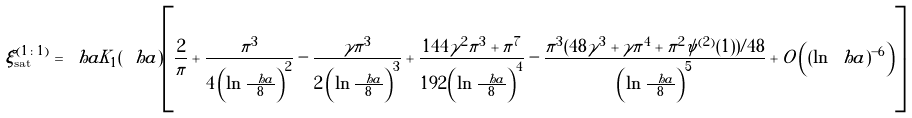Convert formula to latex. <formula><loc_0><loc_0><loc_500><loc_500>\xi _ { \text {sat} } ^ { ( 1 \colon 1 ) } = \ h a K _ { 1 } ( \ h a ) \left [ \frac { 2 } { \pi } + \frac { \pi ^ { 3 } } { 4 \left ( \ln \frac { \ h a } { 8 } \right ) ^ { 2 } } - \frac { \gamma \pi ^ { 3 } } { 2 \left ( \ln \frac { \ h a } { 8 } \right ) ^ { 3 } } + \frac { 1 4 4 \gamma ^ { 2 } \pi ^ { 3 } + \pi ^ { 7 } } { 1 9 2 \left ( \ln \frac { \ h a } { 8 } \right ) ^ { 4 } } - \frac { \pi ^ { 3 } ( 4 8 \gamma ^ { 3 } + \gamma \pi ^ { 4 } + \pi ^ { 2 } \psi ^ { ( 2 ) } ( 1 ) ) / 4 8 } { \left ( \ln \frac { \ h a } { 8 } \right ) ^ { 5 } } + O \left ( ( \ln \ h a ) ^ { - 6 } \right ) \right ]</formula> 